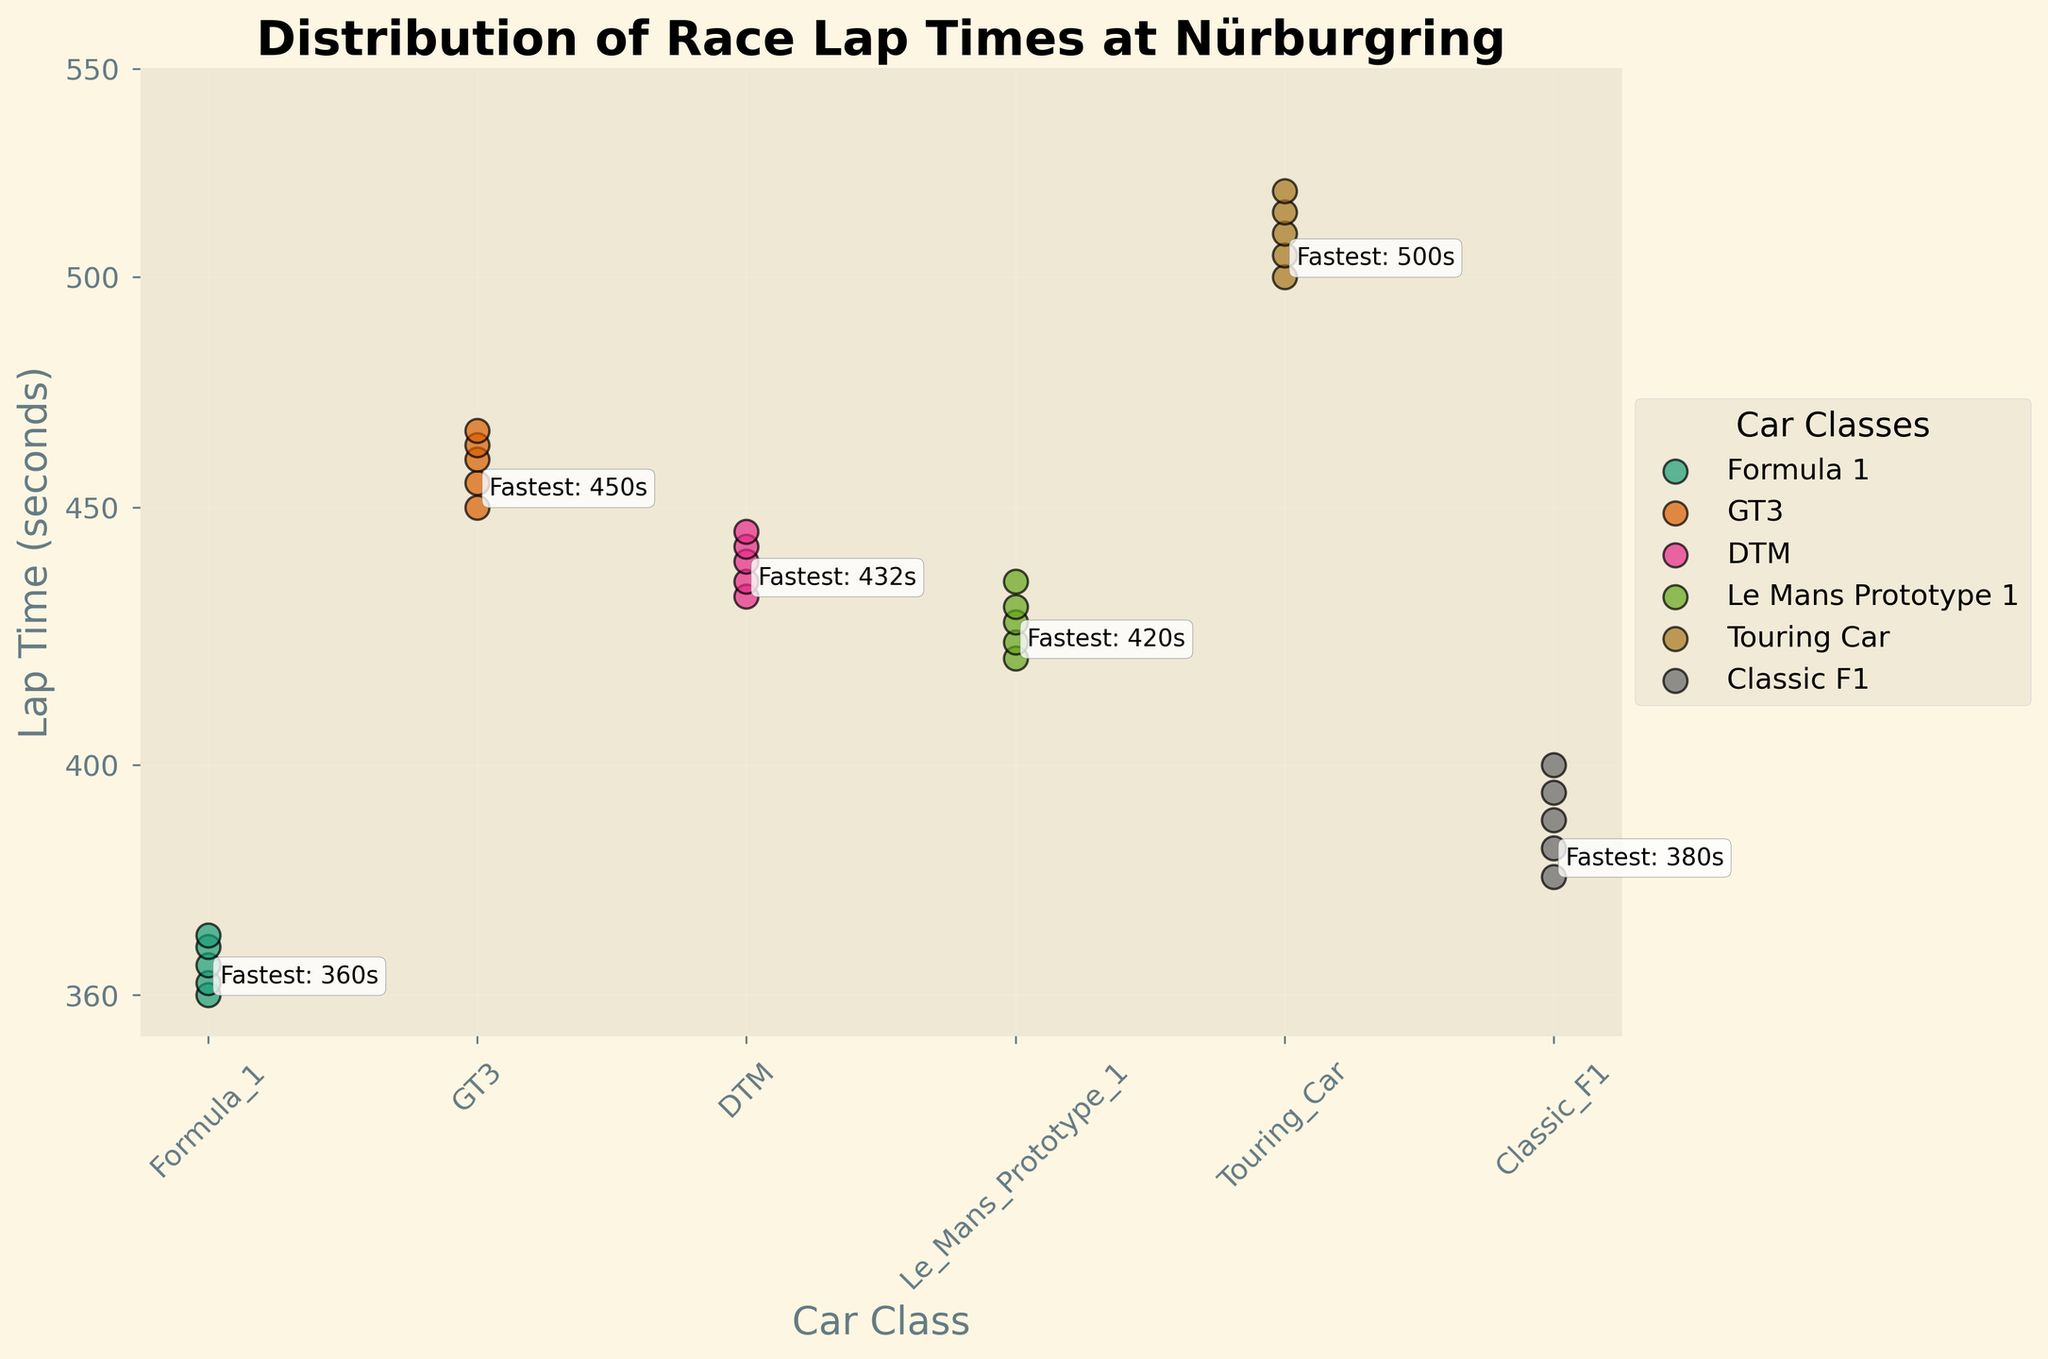What's the title of the figure? The title is written at the top of the plot. It reads "Distribution of Race Lap Times at Nürburgring".
Answer: Distribution of Race Lap Times at Nürburgring Which car class has the fastest lap time? We look at the annotations next to each car class. The annotation mentions the fastest lap time for each class. Formula 1 has the fastest with 360 seconds.
Answer: Formula 1 What is the lap time range for the GT3 car class? We look at the GT3 data points and find the minimum and maximum values. They range from 450 to 466 seconds.
Answer: 450 to 466 seconds How many different car classes are shown in the figure? Each unique color and label represents a car class. Counting them, we find six different classes: Formula 1, GT3, DTM, Le Mans Prototype 1, Touring Car, and Classic F1.
Answer: 6 Which car class takes the longest lap time on average? We find the average lap time for each car class and compare them. Touring Car has the highest average lap time.
Answer: Touring Car What is the lap time difference between the fastest Formula 1 and the slowest Touring Car? The fastest Formula 1 time is 360 seconds, and the slowest Touring Car time is 520 seconds. The difference is 520 - 360.
Answer: 160 seconds How does the log scale affect the visualization of lap times? A log scale compresses the range of values by scaling them logarithmically, making it easier to compare lap times that vary greatly in magnitude.
Answer: It compresses the range, making comparisons easier Compare the fastest lap times of DTM and Classic F1 cars. Which is faster? The fastest DTM time is 432 seconds, while the fastest Classic F1 time is 380 seconds. Classic F1 is faster.
Answer: Classic F1 What are the y-axis ticks and their significance? The y-axis ticks are 360, 400, 450, 500, 550. They show the lap times in seconds with reference points for interpreting the log scale.
Answer: 360, 400, 450, 500, 550 Which car class has the most spread in lap times? The spread can be judged by looking at the range between the minimum and maximum values for each class. Touring Car has the largest range from 500 to 520 seconds.
Answer: Touring Car 